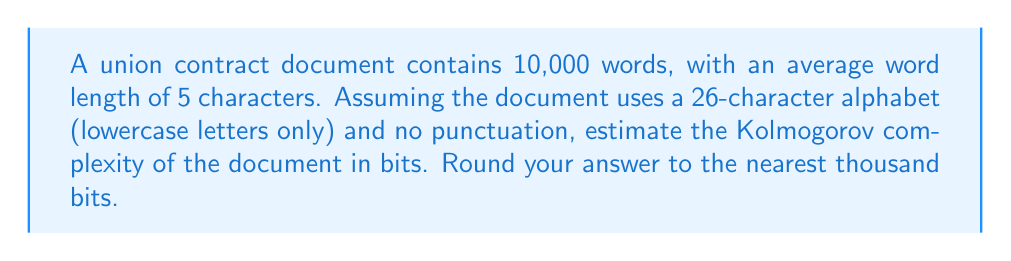Show me your answer to this math problem. To estimate the Kolmogorov complexity of the union contract document, we'll follow these steps:

1) First, calculate the total number of characters in the document:
   $$ \text{Total characters} = 10,000 \text{ words} \times 5 \text{ characters/word} = 50,000 \text{ characters} $$

2) In information theory, the amount of information in a message can be estimated using the formula:
   $$ I = \log_2(n^l) $$
   Where $n$ is the number of possible symbols (alphabet size) and $l$ is the length of the message.

3) In this case:
   $n = 26$ (26 lowercase letters)
   $l = 50,000$ (total characters)

4) Plugging these values into the formula:
   $$ I = \log_2(26^{50,000}) $$

5) Using the logarithm property $\log_a(x^y) = y \log_a(x)$, we can simplify:
   $$ I = 50,000 \times \log_2(26) $$

6) Calculate $\log_2(26)$:
   $$ \log_2(26) \approx 4.7004 $$

7) Now, multiply:
   $$ I = 50,000 \times 4.7004 = 235,020 \text{ bits} $$

8) Rounding to the nearest thousand:
   $$ I \approx 235,000 \text{ bits} $$

This estimate represents an upper bound on the Kolmogorov complexity. The actual complexity might be lower due to patterns and repetitions in the document, which could be compressed.
Answer: 235,000 bits 